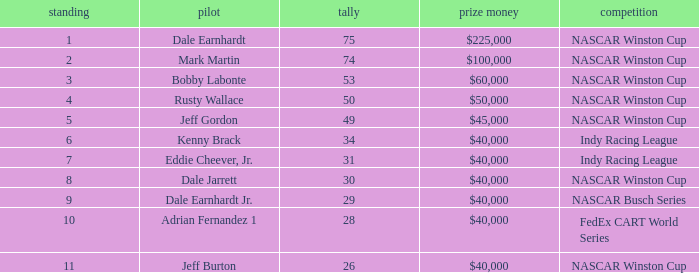How much did Jeff Burton win? $40,000. 